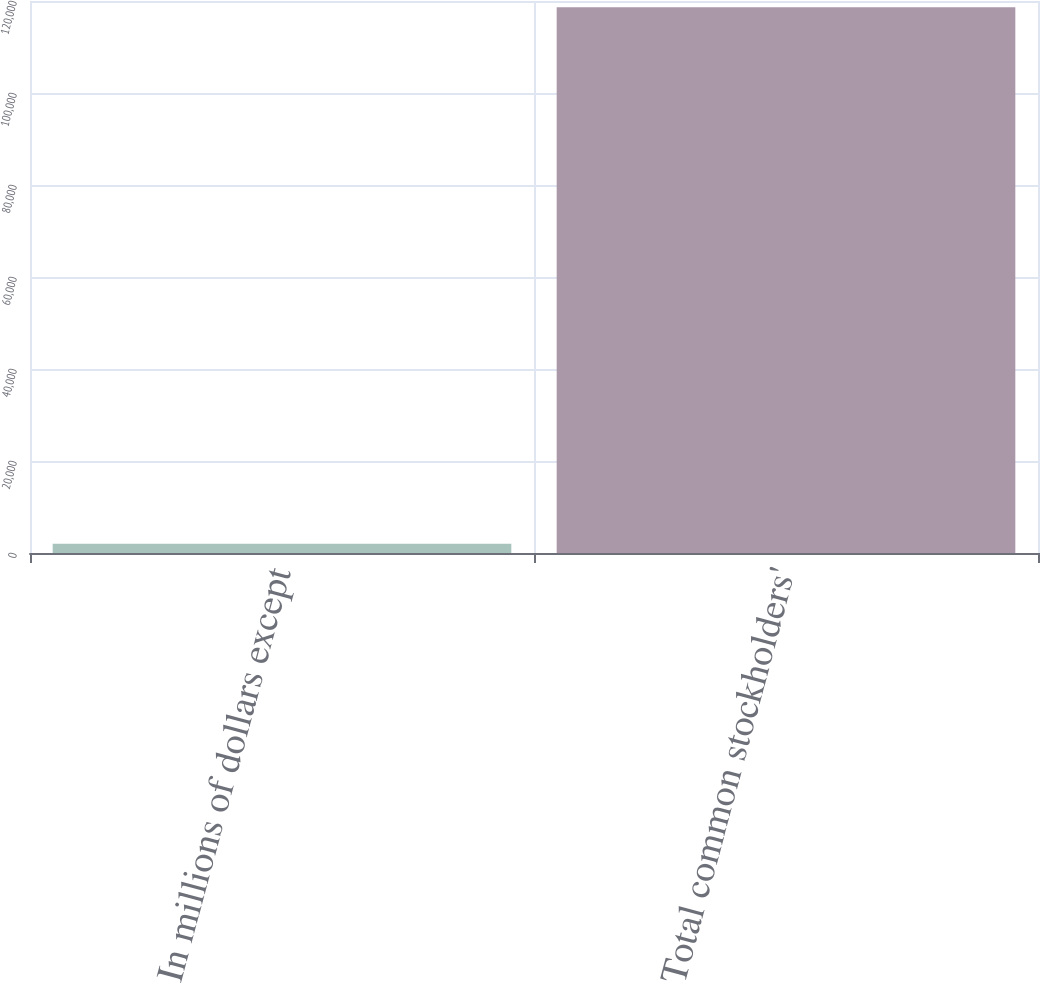<chart> <loc_0><loc_0><loc_500><loc_500><bar_chart><fcel>In millions of dollars except<fcel>Total common stockholders'<nl><fcel>2006<fcel>118632<nl></chart> 